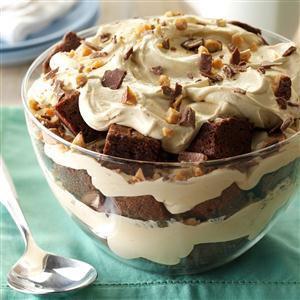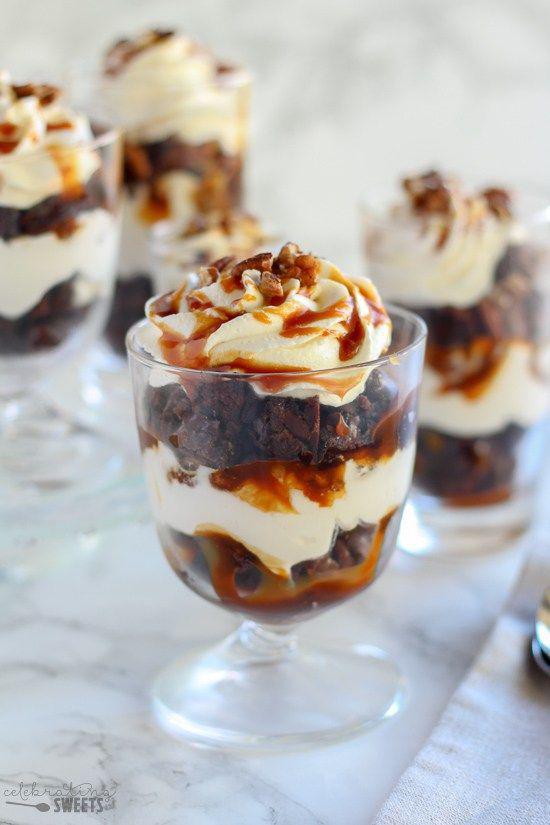The first image is the image on the left, the second image is the image on the right. For the images displayed, is the sentence "The dessert in the image on the right is sitting on a wooden surface." factually correct? Answer yes or no. No. 